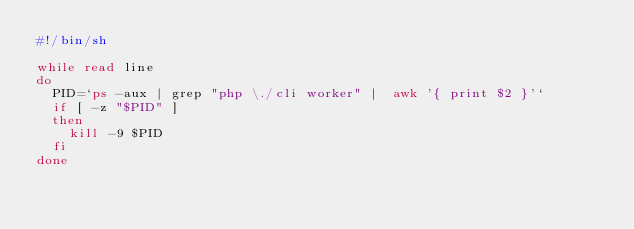Convert code to text. <code><loc_0><loc_0><loc_500><loc_500><_Bash_>#!/bin/sh

while read line
do
	PID=`ps -aux | grep "php \./cli worker" |  awk '{ print $2 }'`
	if [ -z "$PID" ]
	then
		kill -9 $PID
	fi
done

</code> 